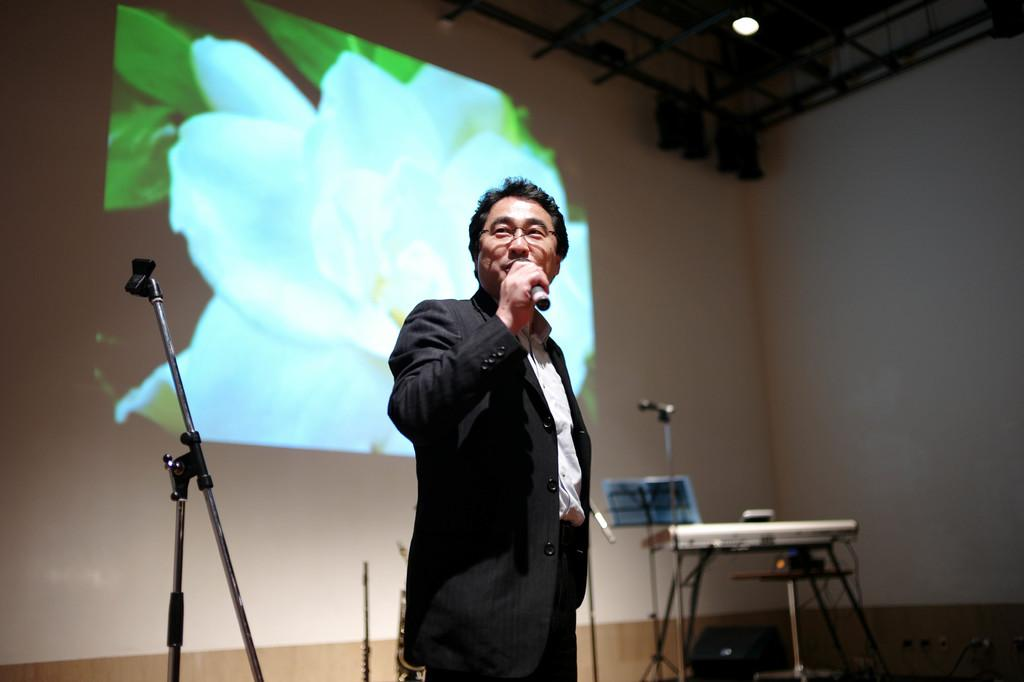What is the man in the image doing? The man is standing in the image and holding a microphone. What objects can be seen in the background of the image? There is a stand, a piano, a board, a screen, and a wall in the background of the image. What might the man be using the microphone for? The man might be using the microphone for speaking or singing. What type of surface is the board in the background? The information provided does not specify the type of surface of the board. What type of stem can be seen growing from the microphone in the image? There is no stem growing from the microphone in the image; it is an electronic device. 